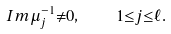<formula> <loc_0><loc_0><loc_500><loc_500>I m { \mu } _ { j } ^ { - 1 } { \ne } 0 , \quad 1 { \leq } j { \leq } \ell .</formula> 